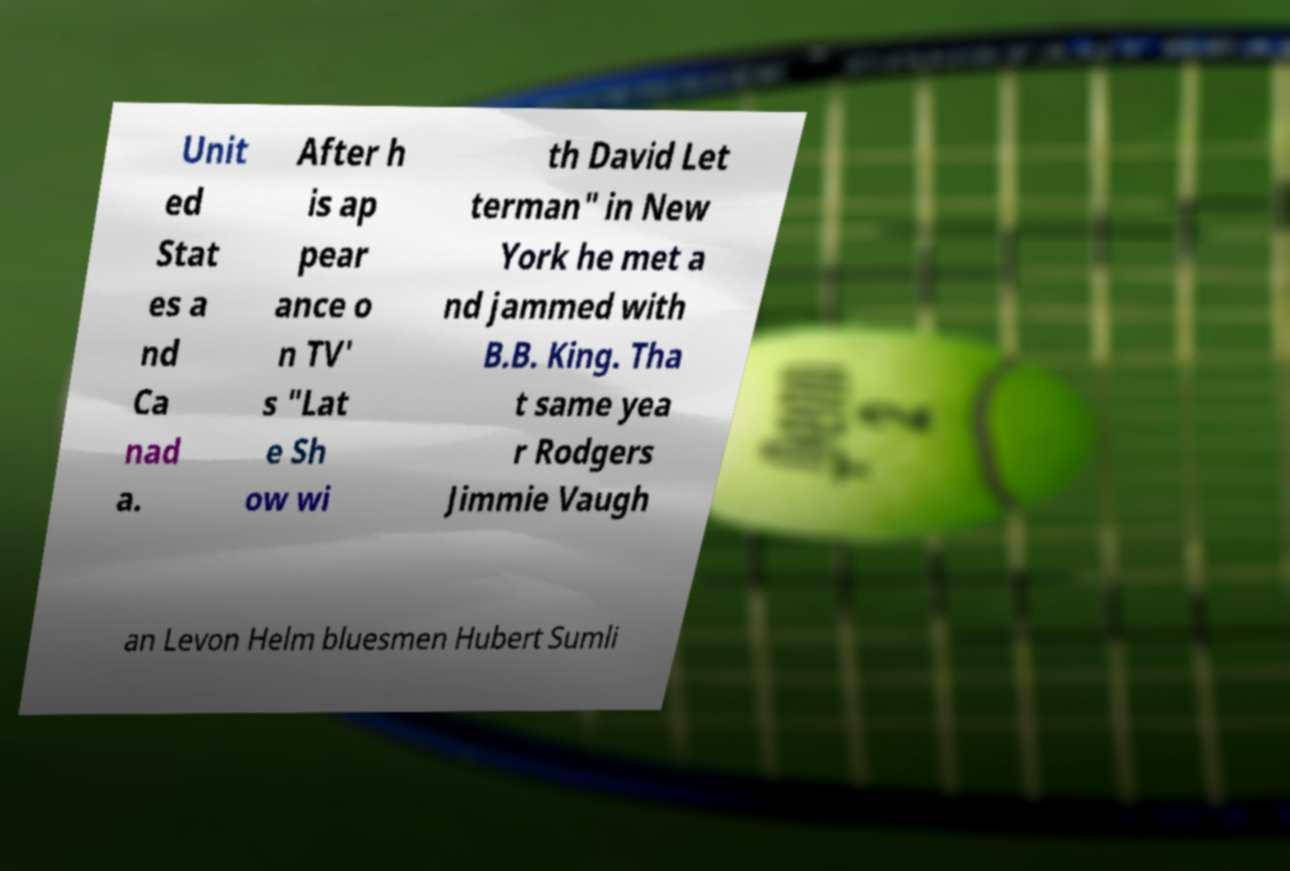Can you read and provide the text displayed in the image?This photo seems to have some interesting text. Can you extract and type it out for me? Unit ed Stat es a nd Ca nad a. After h is ap pear ance o n TV' s "Lat e Sh ow wi th David Let terman" in New York he met a nd jammed with B.B. King. Tha t same yea r Rodgers Jimmie Vaugh an Levon Helm bluesmen Hubert Sumli 